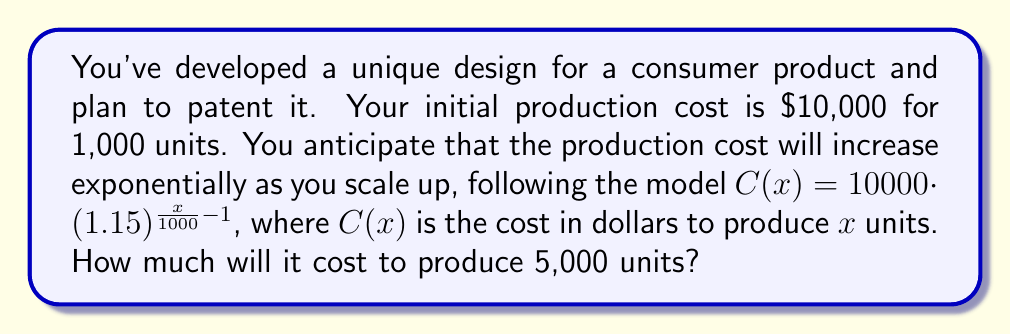Show me your answer to this math problem. Let's approach this step-by-step:

1) We're given the exponential growth model:
   $C(x) = 10000 \cdot (1.15)^{\frac{x}{1000} - 1}$

2) We need to find $C(5000)$, so let's substitute $x = 5000$:
   $C(5000) = 10000 \cdot (1.15)^{\frac{5000}{1000} - 1}$

3) Simplify the exponent:
   $C(5000) = 10000 \cdot (1.15)^{5 - 1}$
   $C(5000) = 10000 \cdot (1.15)^4$

4) Calculate $(1.15)^4$:
   $(1.15)^4 \approx 1.7490625$

5) Multiply:
   $C(5000) = 10000 \cdot 1.7490625$
   $C(5000) = 17,490.625$

6) Round to the nearest dollar:
   $C(5000) \approx 17,491$

Therefore, it will cost approximately $17,491 to produce 5,000 units.
Answer: $17,491 